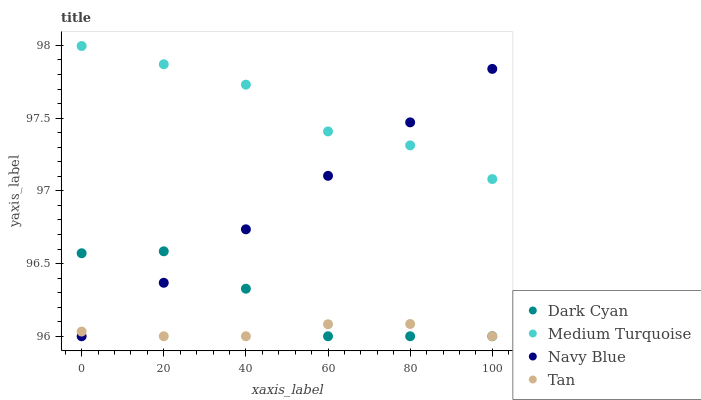Does Tan have the minimum area under the curve?
Answer yes or no. Yes. Does Medium Turquoise have the maximum area under the curve?
Answer yes or no. Yes. Does Navy Blue have the minimum area under the curve?
Answer yes or no. No. Does Navy Blue have the maximum area under the curve?
Answer yes or no. No. Is Navy Blue the smoothest?
Answer yes or no. Yes. Is Dark Cyan the roughest?
Answer yes or no. Yes. Is Tan the smoothest?
Answer yes or no. No. Is Tan the roughest?
Answer yes or no. No. Does Dark Cyan have the lowest value?
Answer yes or no. Yes. Does Medium Turquoise have the lowest value?
Answer yes or no. No. Does Medium Turquoise have the highest value?
Answer yes or no. Yes. Does Navy Blue have the highest value?
Answer yes or no. No. Is Dark Cyan less than Medium Turquoise?
Answer yes or no. Yes. Is Medium Turquoise greater than Tan?
Answer yes or no. Yes. Does Medium Turquoise intersect Navy Blue?
Answer yes or no. Yes. Is Medium Turquoise less than Navy Blue?
Answer yes or no. No. Is Medium Turquoise greater than Navy Blue?
Answer yes or no. No. Does Dark Cyan intersect Medium Turquoise?
Answer yes or no. No. 